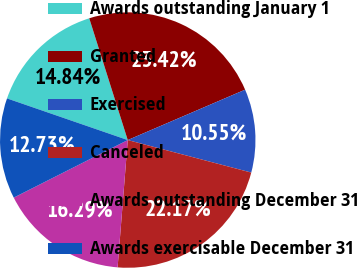Convert chart to OTSL. <chart><loc_0><loc_0><loc_500><loc_500><pie_chart><fcel>Awards outstanding January 1<fcel>Granted<fcel>Exercised<fcel>Canceled<fcel>Awards outstanding December 31<fcel>Awards exercisable December 31<nl><fcel>14.84%<fcel>23.42%<fcel>10.55%<fcel>22.17%<fcel>16.29%<fcel>12.73%<nl></chart> 